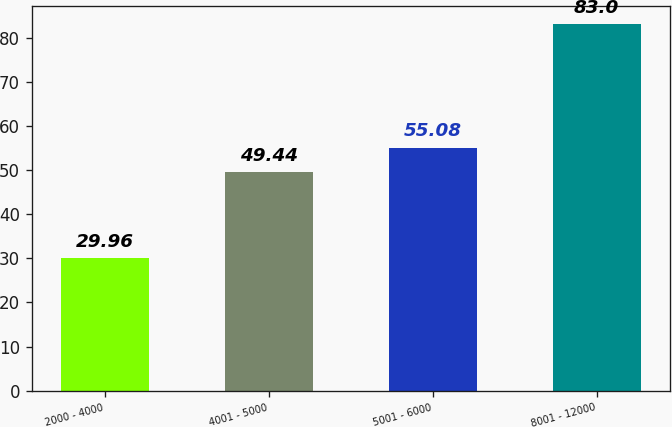<chart> <loc_0><loc_0><loc_500><loc_500><bar_chart><fcel>2000 - 4000<fcel>4001 - 5000<fcel>5001 - 6000<fcel>8001 - 12000<nl><fcel>29.96<fcel>49.44<fcel>55.08<fcel>83<nl></chart> 